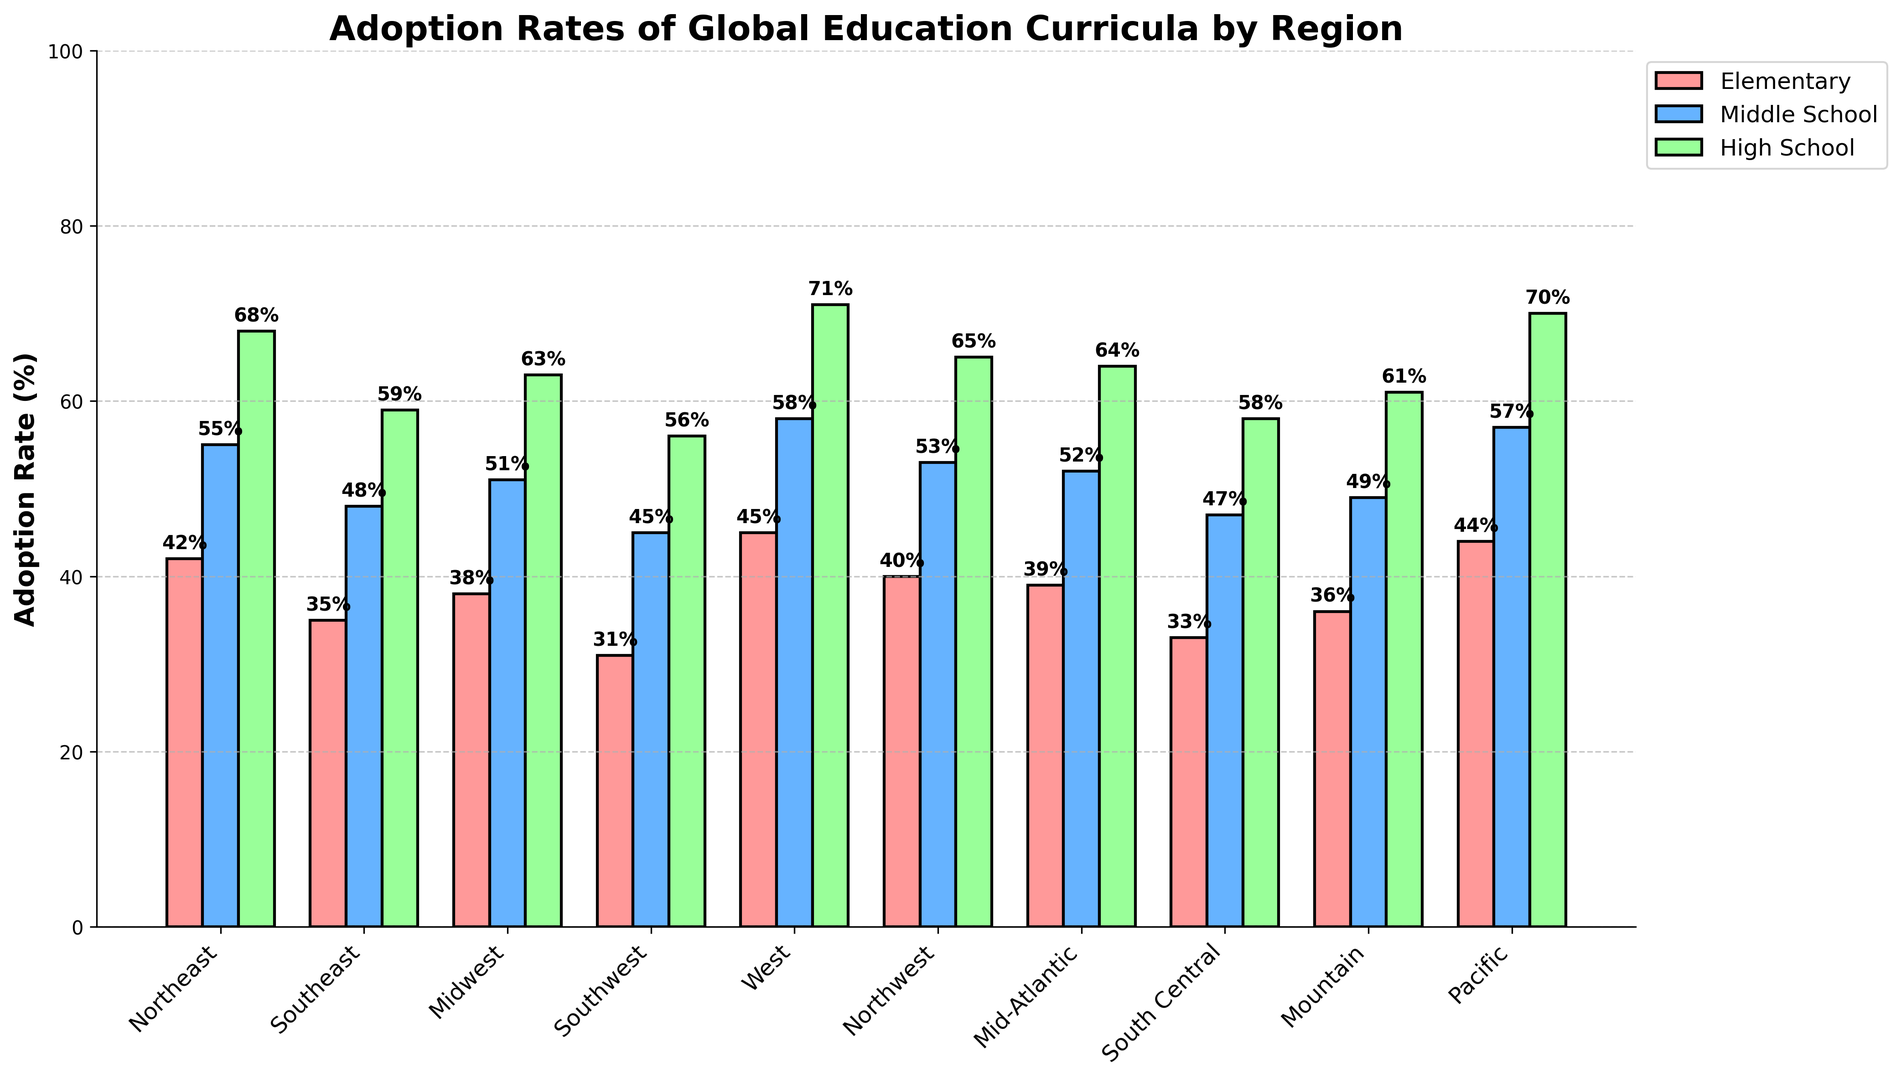Which region has the highest adoption rate for high school curricula? Look for the tallest bar in the high school category (green color). The West region has a height of 71%, which is the highest among all regions.
Answer: West Which region has the lowest adoption rate for elementary school curricula? Observe the shortest bar in the elementary school category (red color). The Southwest region has the shortest bar, with a height of 31%.
Answer: Southwest What is the average adoption rate for elementary curricula across all regions? Sum the adoption rates for elementary curricula (42 + 35 + 38 + 31 + 45 + 40 + 39 + 33 + 36 + 44) which equals 383, and divide by the number of regions (10). Therefore, the average is 383/10 = 38.3%.
Answer: 38.3% How does the adoption rate for middle school in the Pacific region compare to that of the South Central region? Compare the heights of the bars corresponding to the middle school category (blue color) for both regions. Pacific has a 57% adoption rate, while South Central has 47%. Hence, Pacific's adoption rate is higher.
Answer: Pacific What is the combined adoption rate of the global education curricula in the Northeast region across all school levels? Add the adoption rates for elementary (42), middle school (55), and high school (68) in the Northeast region. Thus, 42 + 55 + 68 = 165%.
Answer: 165% What is the difference between the highest and lowest adoption rates for middle school curricula? Identify the highest and lowest values in the middle school category (blue color). The highest is in the West (58%) and the lowest is in the Southwest (45%). The difference is 58% - 45% = 13%.
Answer: 13% In which region is the combined adoption rate for high school and middle school curricula the highest? For each region, sum the height of the bars for high school and middle school categories (green and blue respectively) and compare. West region sums to 58% + 71% = 129%, which is the highest combined rate.
Answer: West 